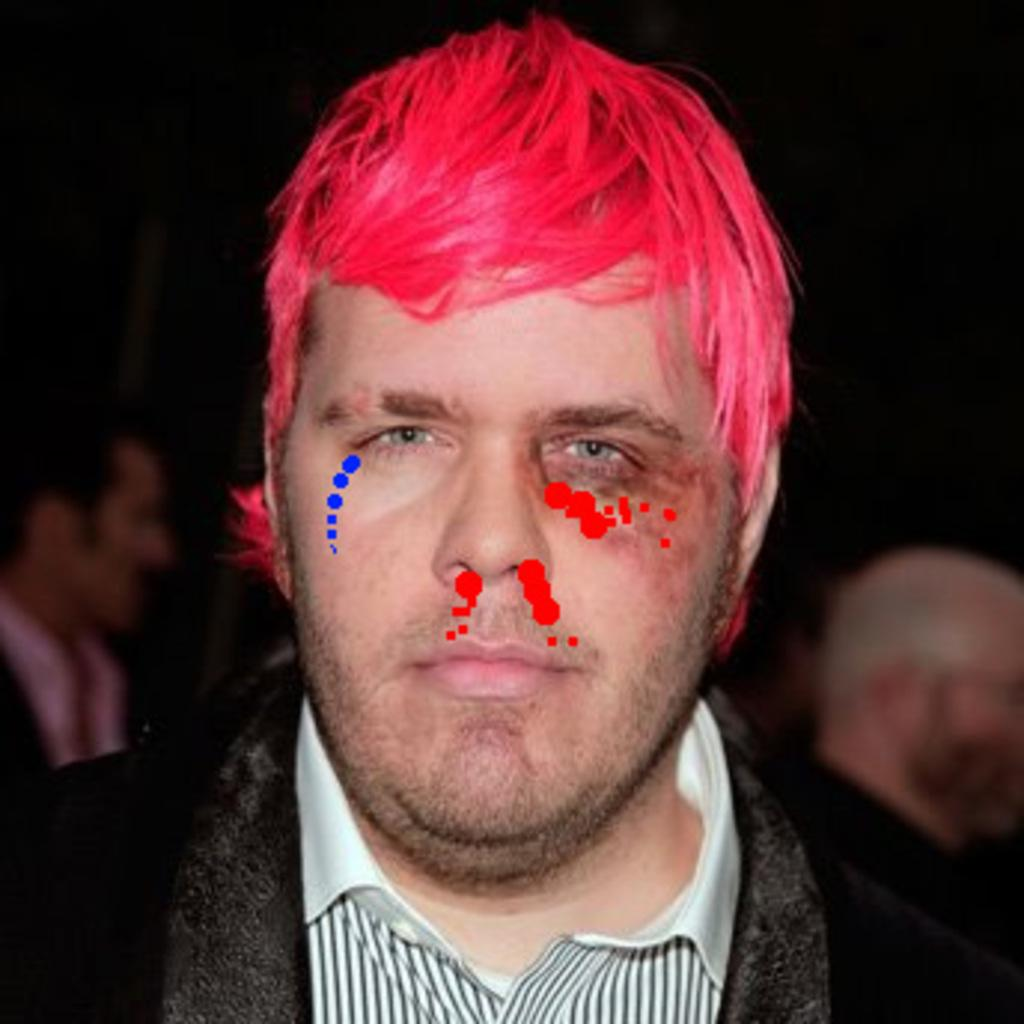Who is the main subject in the image? There is a man in the image. What can be observed about the background of the image? The background of the image is dark. Are there any other people visible in the image? Yes, there are people visible in the background of the image. What type of bottle is the cook using in the image? There is no cook or bottle present in the image; it features a man and a dark background. 